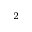<formula> <loc_0><loc_0><loc_500><loc_500>_ { 2 }</formula> 